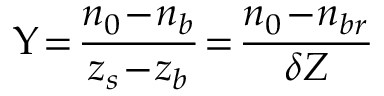Convert formula to latex. <formula><loc_0><loc_0><loc_500><loc_500>\Upsilon \, = \, \frac { n _ { 0 } \, - \, n _ { b } } { z _ { s } \, - \, z _ { b } } \, = \, \frac { n _ { 0 } \, - \, n _ { b r } } { \delta Z }</formula> 